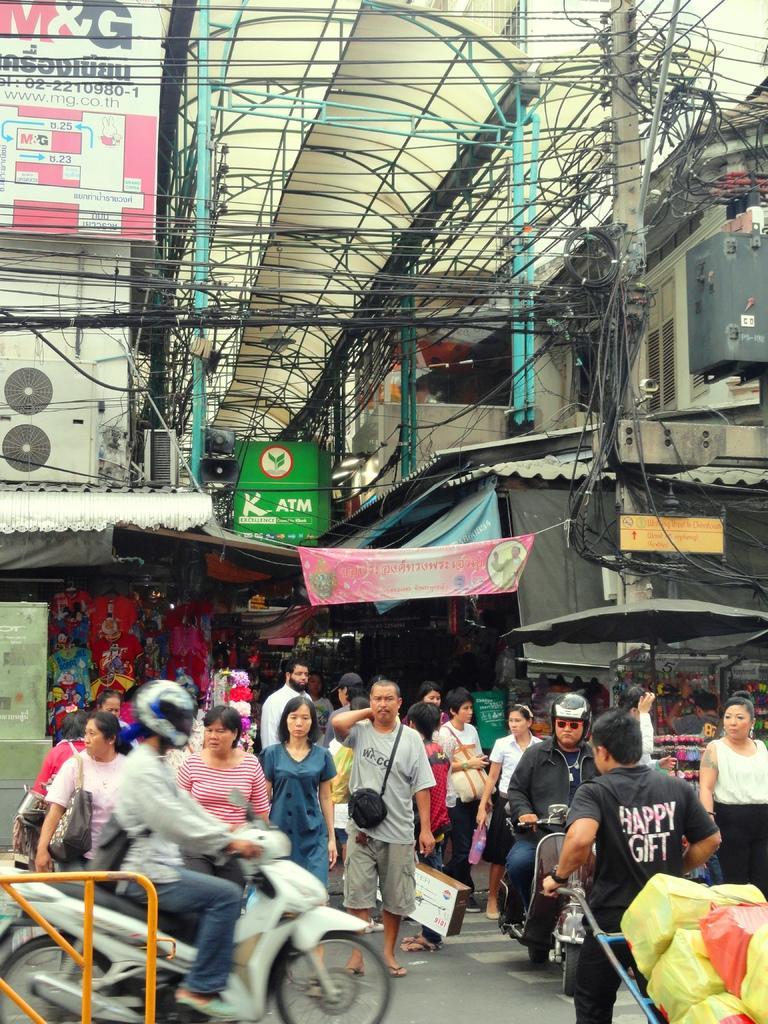In one or two sentences, can you explain what this image depicts? In this image we can see this person wearing black T-shirt is moving the trolley on which we can see some things. Here we can see these two persons wearing helmets and moving on the vehicles and these people are walking on the road. In the background, we can see an umbrella, pole, wires, banners, boards, transformer and the building. 